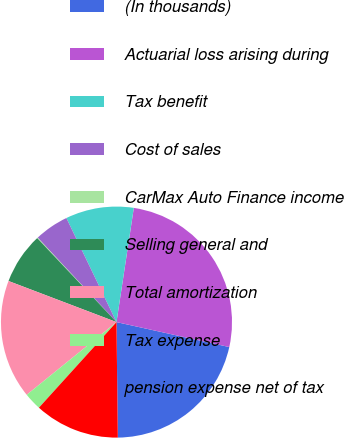Convert chart. <chart><loc_0><loc_0><loc_500><loc_500><pie_chart><fcel>(In thousands)<fcel>Actuarial loss arising during<fcel>Tax benefit<fcel>Cost of sales<fcel>CarMax Auto Finance income<fcel>Selling general and<fcel>Total amortization<fcel>Tax expense<fcel>pension expense net of tax<nl><fcel>21.35%<fcel>26.07%<fcel>9.54%<fcel>4.81%<fcel>0.09%<fcel>7.17%<fcel>16.62%<fcel>2.45%<fcel>11.9%<nl></chart> 